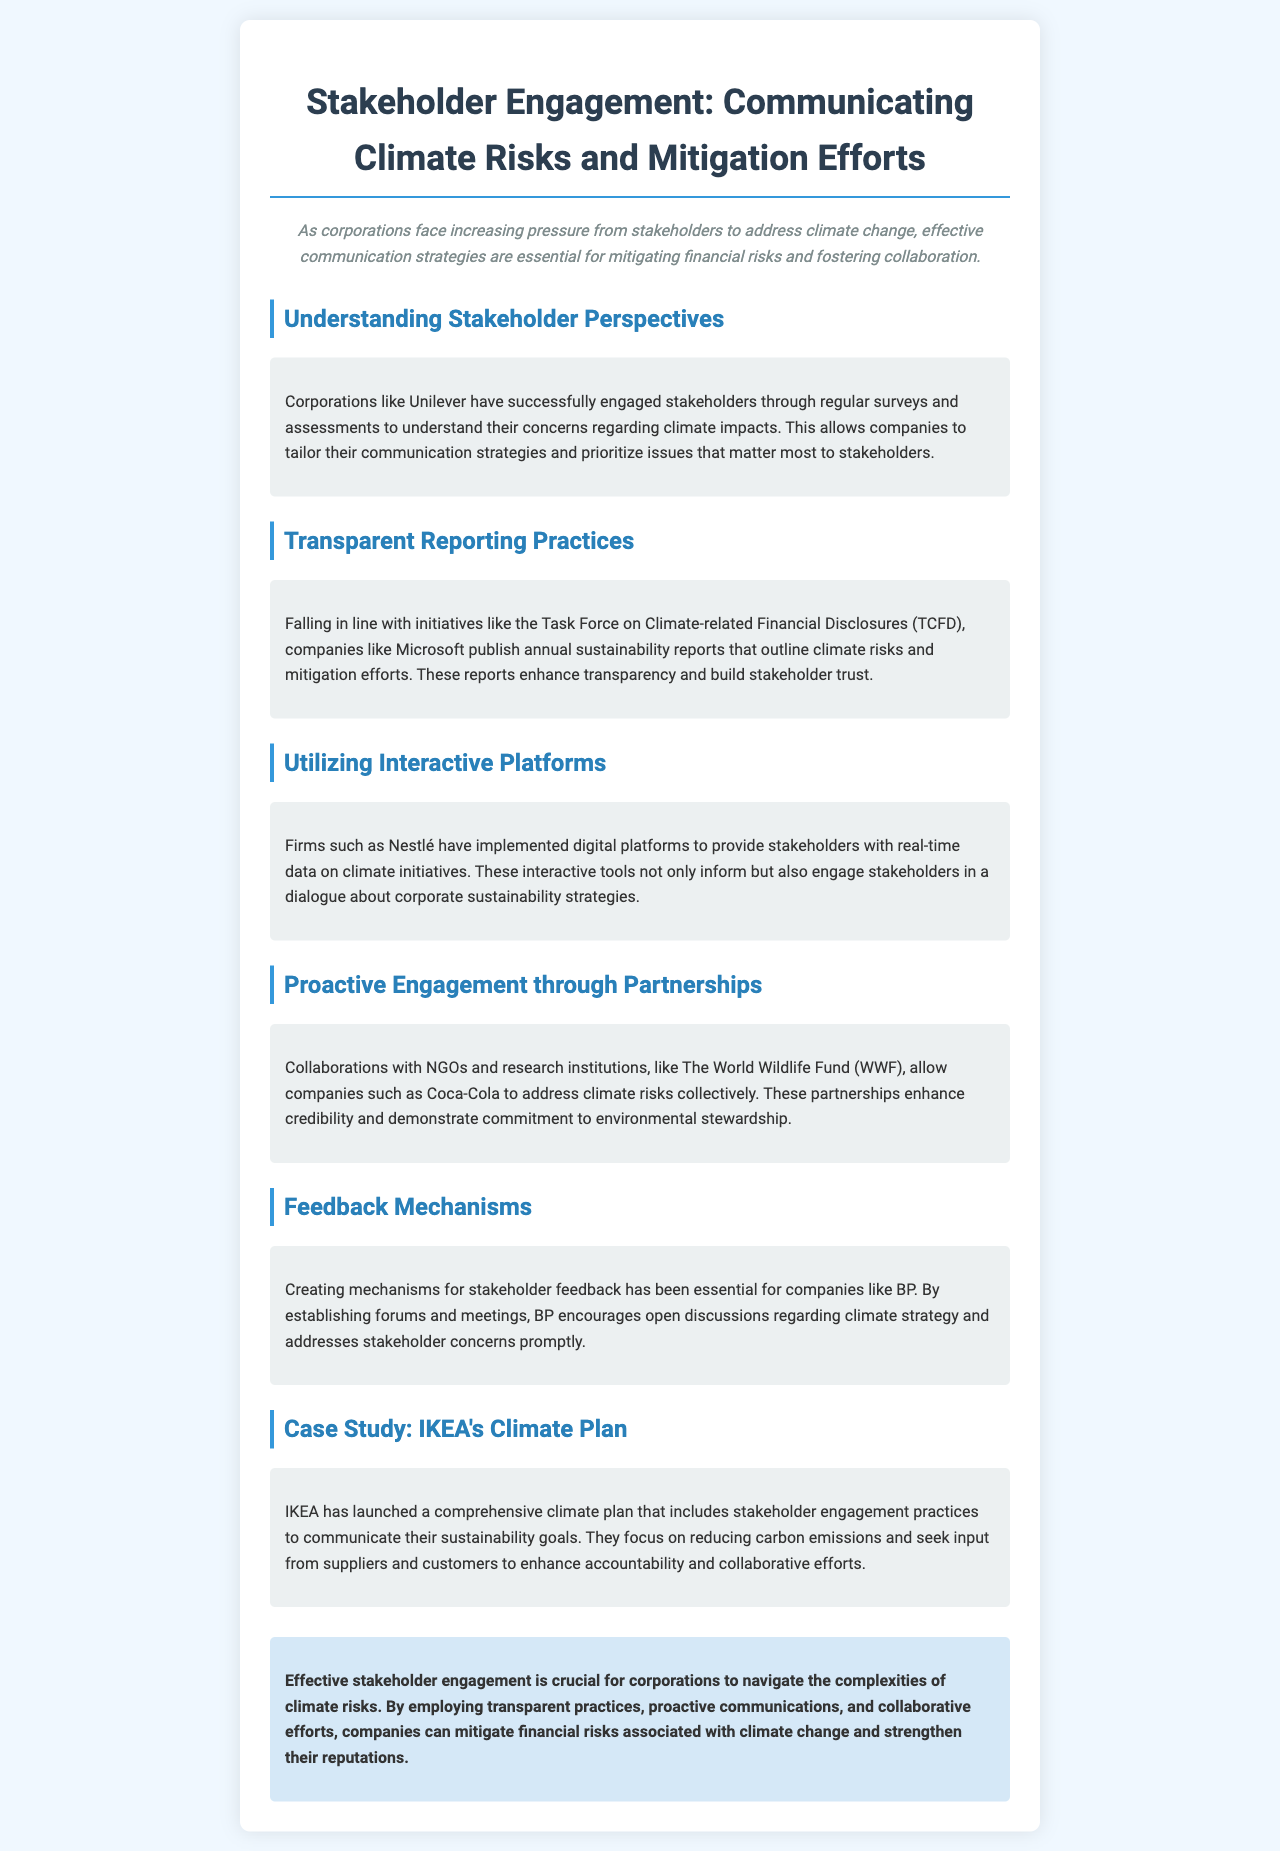What corporation is mentioned as successfully engaging stakeholders? The document states that Unilever has successfully engaged stakeholders through regular surveys and assessments.
Answer: Unilever Which initiative is associated with transparent reporting practices? The newsletter refers to the Task Force on Climate-related Financial Disclosures (TCFD) as an initiative for reporting climate risks.
Answer: TCFD What type of platforms has Nestlé implemented for stakeholder engagement? The document mentions that Nestlé has implemented digital platforms to provide real-time data on climate initiatives.
Answer: Digital platforms Who collaborates with Coca-Cola to address climate risks? The document states that Coca-Cola collaborates with NGOs and research institutions like The World Wildlife Fund (WWF).
Answer: WWF What is one method BP uses to encourage stakeholder feedback? The newsletter indicates that BP encourages open discussions through forums and meetings.
Answer: Forums and meetings What is the focus of IKEA's comprehensive climate plan? The document specifies that IKEA focuses on reducing carbon emissions.
Answer: Reducing carbon emissions What is a key benefit of publishing annual sustainability reports, according to Microsoft? The document suggests that publishing these reports enhances transparency and builds stakeholder trust.
Answer: Builds stakeholder trust How does IKEA seek input for their sustainability goals? The newsletter states that IKEA seeks input from suppliers and customers to enhance accountability and collaboration.
Answer: Suppliers and customers 